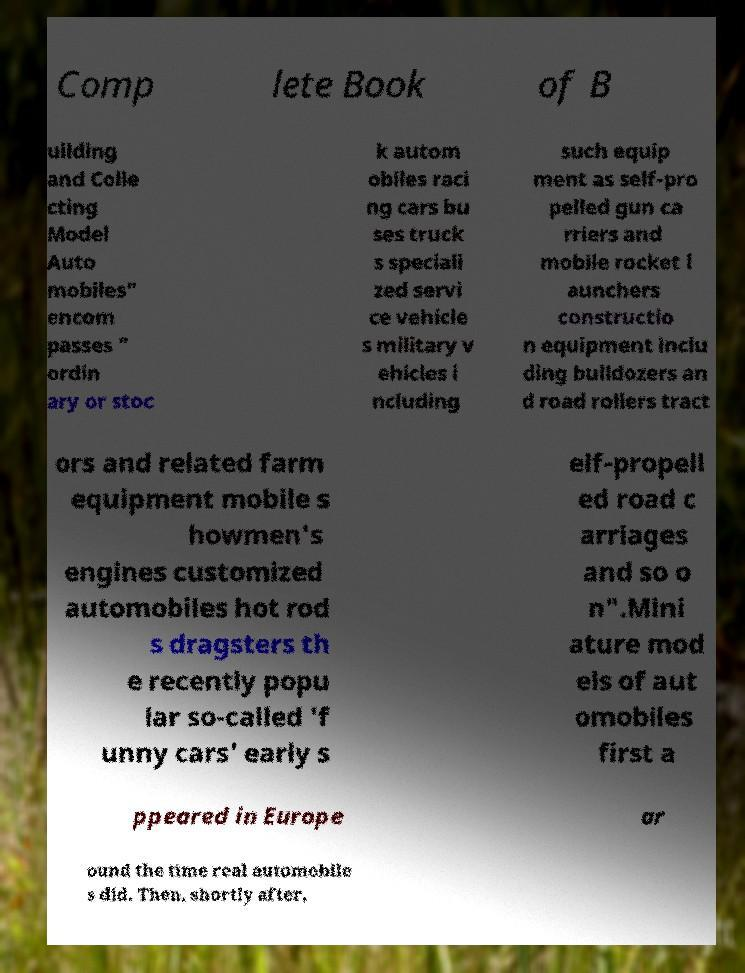Could you assist in decoding the text presented in this image and type it out clearly? Comp lete Book of B uilding and Colle cting Model Auto mobiles" encom passes " ordin ary or stoc k autom obiles raci ng cars bu ses truck s speciali zed servi ce vehicle s military v ehicles i ncluding such equip ment as self-pro pelled gun ca rriers and mobile rocket l aunchers constructio n equipment inclu ding bulldozers an d road rollers tract ors and related farm equipment mobile s howmen's engines customized automobiles hot rod s dragsters th e recently popu lar so-called 'f unny cars' early s elf-propell ed road c arriages and so o n".Mini ature mod els of aut omobiles first a ppeared in Europe ar ound the time real automobile s did. Then, shortly after, 